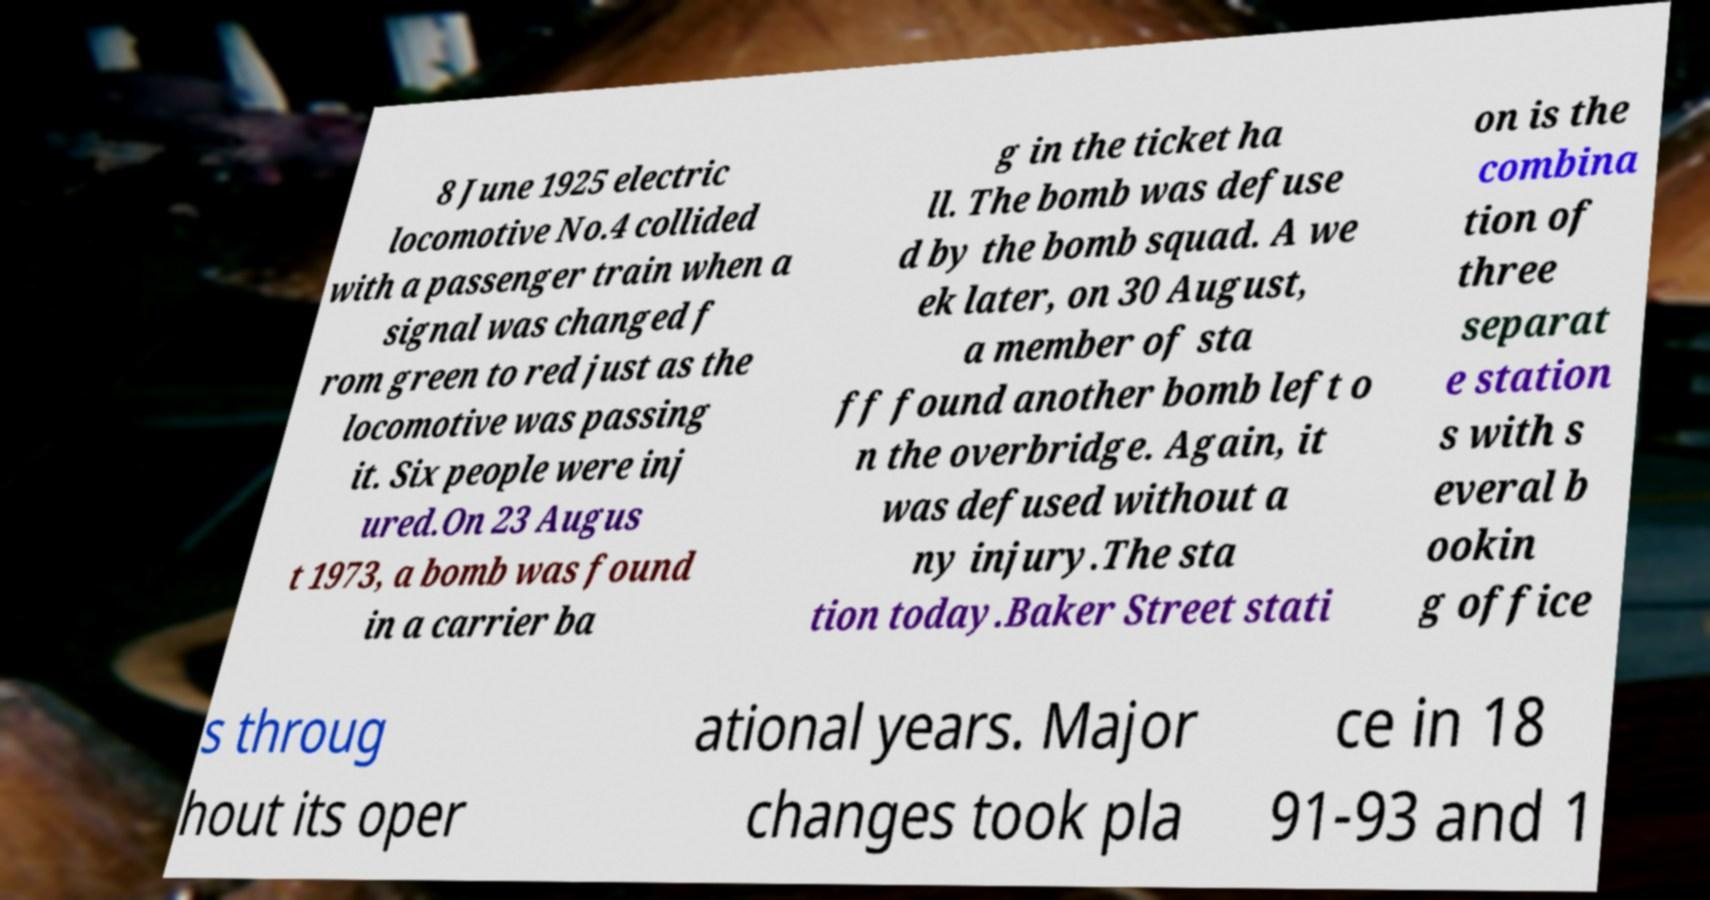What messages or text are displayed in this image? I need them in a readable, typed format. 8 June 1925 electric locomotive No.4 collided with a passenger train when a signal was changed f rom green to red just as the locomotive was passing it. Six people were inj ured.On 23 Augus t 1973, a bomb was found in a carrier ba g in the ticket ha ll. The bomb was defuse d by the bomb squad. A we ek later, on 30 August, a member of sta ff found another bomb left o n the overbridge. Again, it was defused without a ny injury.The sta tion today.Baker Street stati on is the combina tion of three separat e station s with s everal b ookin g office s throug hout its oper ational years. Major changes took pla ce in 18 91-93 and 1 